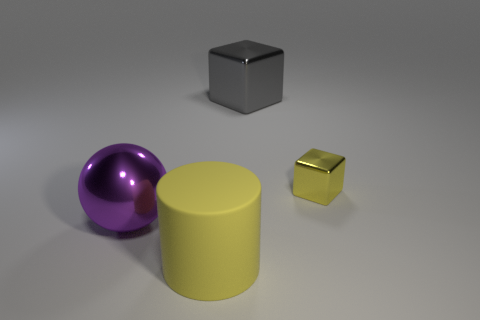Subtract all gray cubes. How many cubes are left? 1 Subtract all brown balls. Subtract all green cubes. How many balls are left? 1 Add 1 big gray metallic things. How many objects exist? 5 Subtract 1 spheres. How many spheres are left? 0 Subtract all yellow cylinders. Subtract all yellow cylinders. How many objects are left? 2 Add 2 large purple things. How many large purple things are left? 3 Add 2 large metallic cubes. How many large metallic cubes exist? 3 Subtract 0 cyan cylinders. How many objects are left? 4 Subtract all spheres. How many objects are left? 3 Subtract all cyan balls. How many gray cylinders are left? 0 